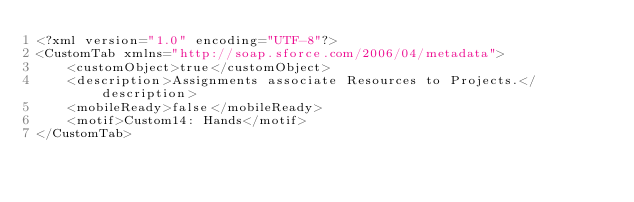Convert code to text. <code><loc_0><loc_0><loc_500><loc_500><_SQL_><?xml version="1.0" encoding="UTF-8"?>
<CustomTab xmlns="http://soap.sforce.com/2006/04/metadata">
    <customObject>true</customObject>
    <description>Assignments associate Resources to Projects.</description>
    <mobileReady>false</mobileReady>
    <motif>Custom14: Hands</motif>
</CustomTab>
</code> 